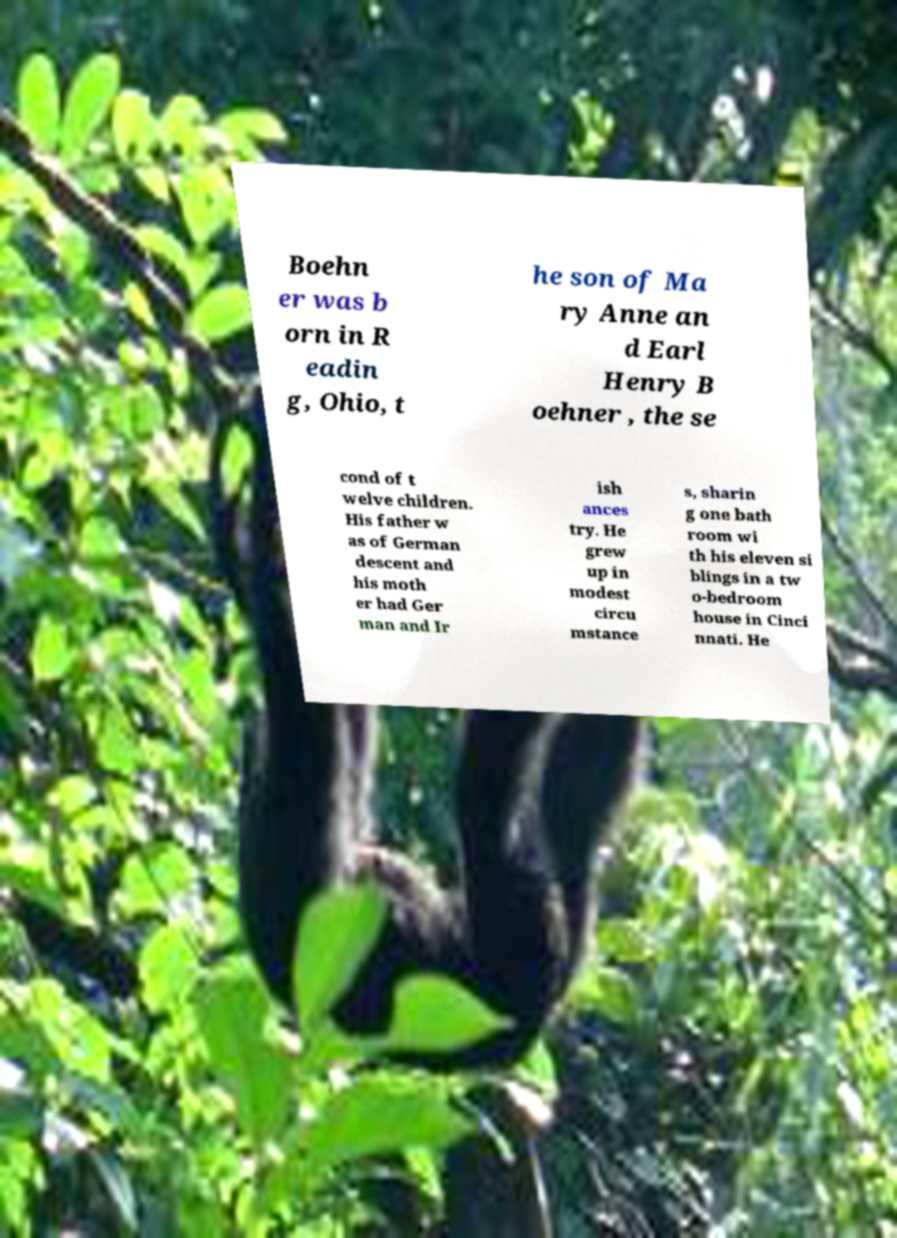What messages or text are displayed in this image? I need them in a readable, typed format. Boehn er was b orn in R eadin g, Ohio, t he son of Ma ry Anne an d Earl Henry B oehner , the se cond of t welve children. His father w as of German descent and his moth er had Ger man and Ir ish ances try. He grew up in modest circu mstance s, sharin g one bath room wi th his eleven si blings in a tw o-bedroom house in Cinci nnati. He 